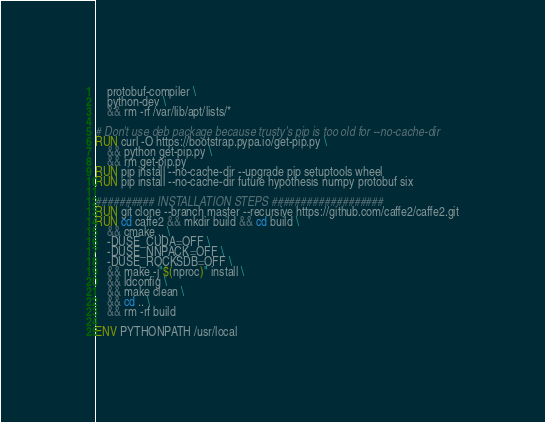<code> <loc_0><loc_0><loc_500><loc_500><_Dockerfile_>    protobuf-compiler \
    python-dev \
    && rm -rf /var/lib/apt/lists/*

# Don't use deb package because trusty's pip is too old for --no-cache-dir
RUN curl -O https://bootstrap.pypa.io/get-pip.py \
    && python get-pip.py \
    && rm get-pip.py
RUN pip install --no-cache-dir --upgrade pip setuptools wheel
RUN pip install --no-cache-dir future hypothesis numpy protobuf six

########## INSTALLATION STEPS ###################
RUN git clone --branch master --recursive https://github.com/caffe2/caffe2.git
RUN cd caffe2 && mkdir build && cd build \
    && cmake .. \
    -DUSE_CUDA=OFF \
    -DUSE_NNPACK=OFF \
    -DUSE_ROCKSDB=OFF \
    && make -j"$(nproc)" install \
    && ldconfig \
    && make clean \
    && cd .. \
    && rm -rf build

ENV PYTHONPATH /usr/local
</code> 